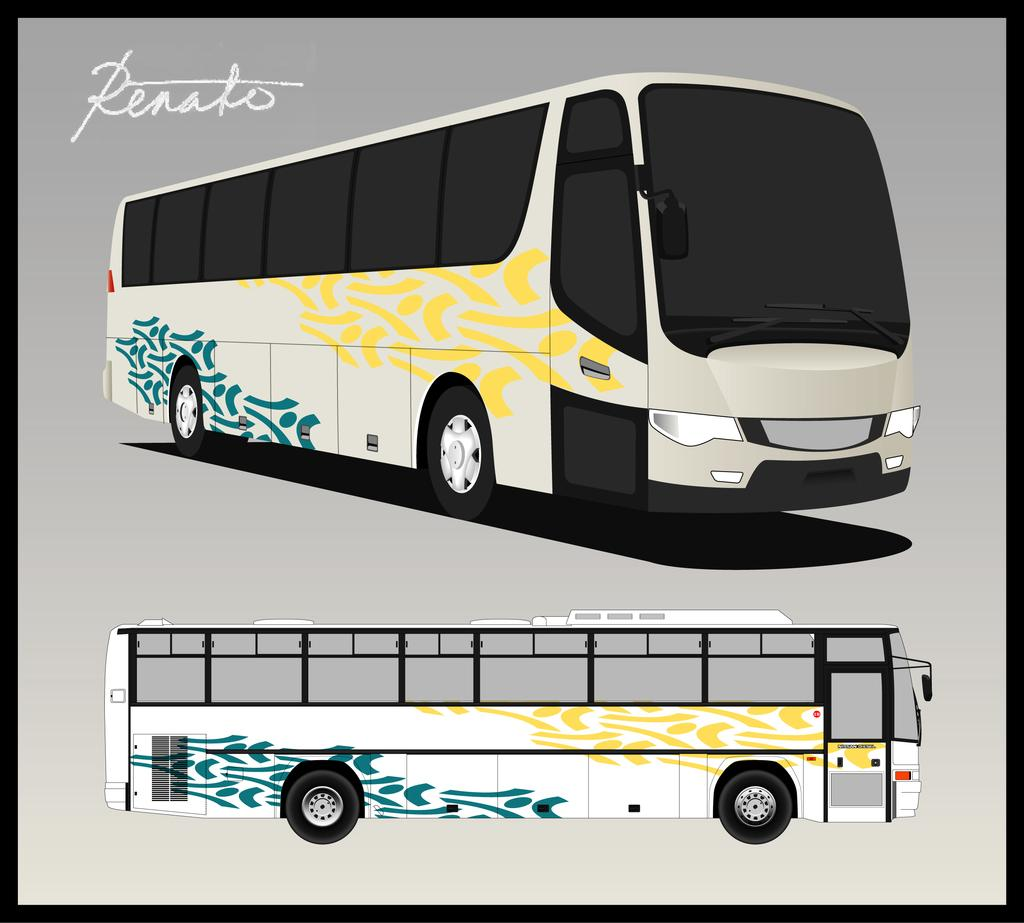<image>
Give a short and clear explanation of the subsequent image. An image of a Renato bus shows the bus with yellow and green accents. 